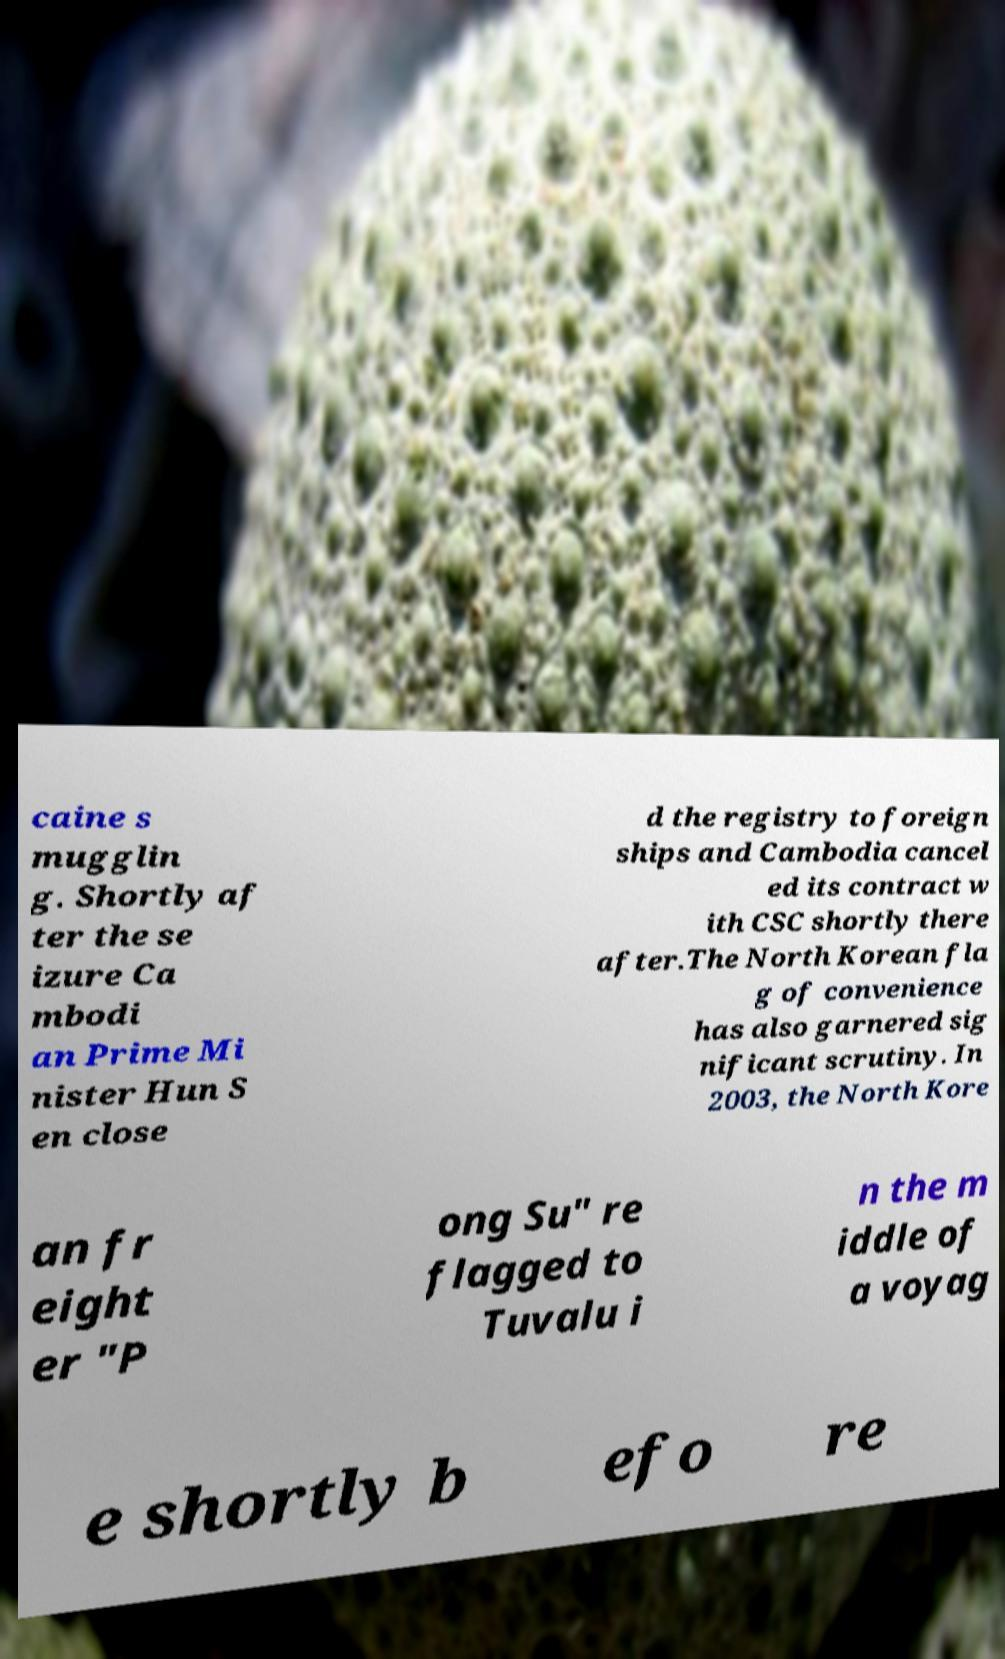For documentation purposes, I need the text within this image transcribed. Could you provide that? caine s mugglin g. Shortly af ter the se izure Ca mbodi an Prime Mi nister Hun S en close d the registry to foreign ships and Cambodia cancel ed its contract w ith CSC shortly there after.The North Korean fla g of convenience has also garnered sig nificant scrutiny. In 2003, the North Kore an fr eight er "P ong Su" re flagged to Tuvalu i n the m iddle of a voyag e shortly b efo re 